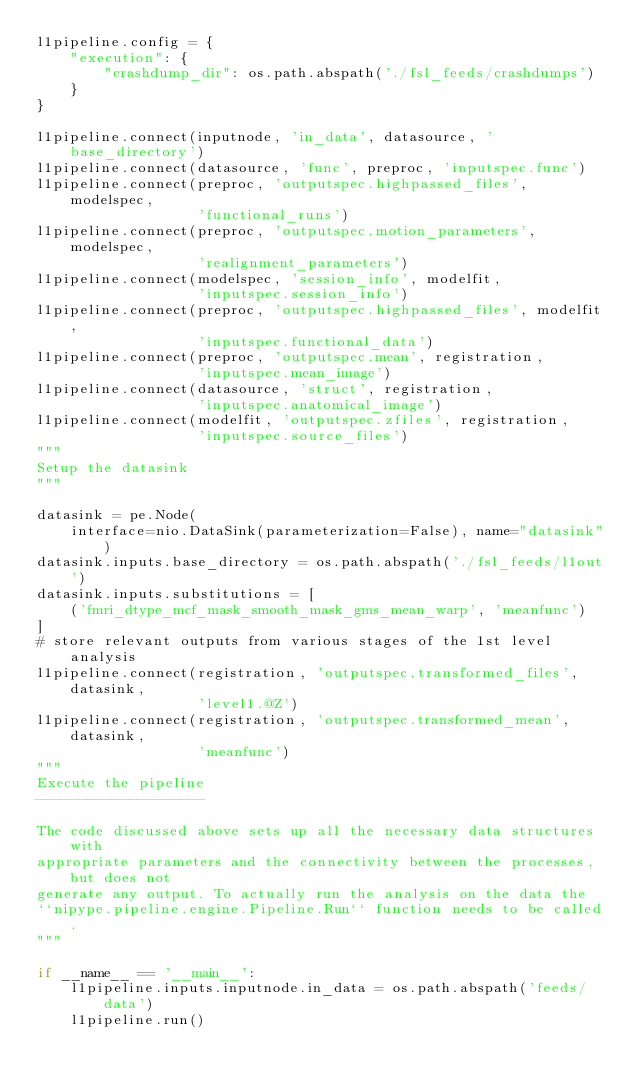<code> <loc_0><loc_0><loc_500><loc_500><_Python_>l1pipeline.config = {
    "execution": {
        "crashdump_dir": os.path.abspath('./fsl_feeds/crashdumps')
    }
}

l1pipeline.connect(inputnode, 'in_data', datasource, 'base_directory')
l1pipeline.connect(datasource, 'func', preproc, 'inputspec.func')
l1pipeline.connect(preproc, 'outputspec.highpassed_files', modelspec,
                   'functional_runs')
l1pipeline.connect(preproc, 'outputspec.motion_parameters', modelspec,
                   'realignment_parameters')
l1pipeline.connect(modelspec, 'session_info', modelfit,
                   'inputspec.session_info')
l1pipeline.connect(preproc, 'outputspec.highpassed_files', modelfit,
                   'inputspec.functional_data')
l1pipeline.connect(preproc, 'outputspec.mean', registration,
                   'inputspec.mean_image')
l1pipeline.connect(datasource, 'struct', registration,
                   'inputspec.anatomical_image')
l1pipeline.connect(modelfit, 'outputspec.zfiles', registration,
                   'inputspec.source_files')
"""
Setup the datasink
"""

datasink = pe.Node(
    interface=nio.DataSink(parameterization=False), name="datasink")
datasink.inputs.base_directory = os.path.abspath('./fsl_feeds/l1out')
datasink.inputs.substitutions = [
    ('fmri_dtype_mcf_mask_smooth_mask_gms_mean_warp', 'meanfunc')
]
# store relevant outputs from various stages of the 1st level analysis
l1pipeline.connect(registration, 'outputspec.transformed_files', datasink,
                   'level1.@Z')
l1pipeline.connect(registration, 'outputspec.transformed_mean', datasink,
                   'meanfunc')
"""
Execute the pipeline
--------------------

The code discussed above sets up all the necessary data structures with
appropriate parameters and the connectivity between the processes, but does not
generate any output. To actually run the analysis on the data the
``nipype.pipeline.engine.Pipeline.Run`` function needs to be called.
"""

if __name__ == '__main__':
    l1pipeline.inputs.inputnode.in_data = os.path.abspath('feeds/data')
    l1pipeline.run()
</code> 